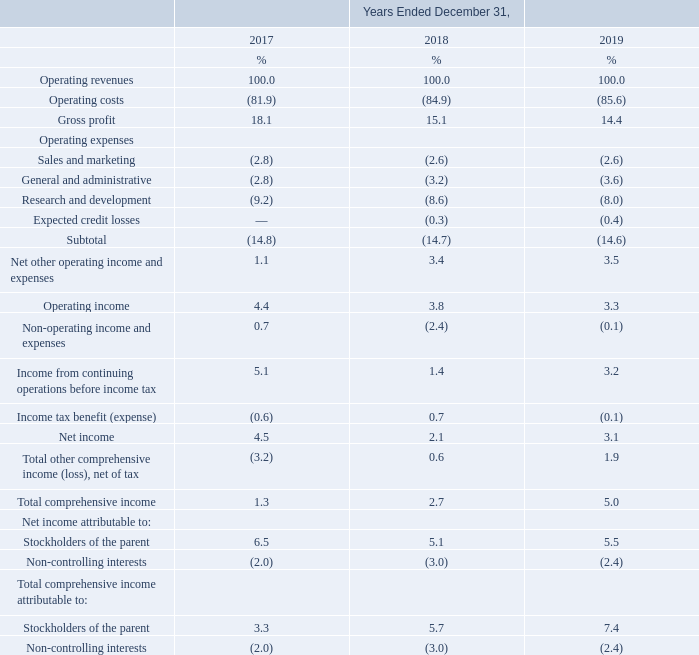Year Ended December 31, 2019 Compared to Year Ended December 31, 2018
Operating revenues. Operating revenues decreased by 2.0% from NT$151,253 million in 2018 to NT$148,202 million (US$4,955 million) in
2019, primarily due to decreased other operating revenues, decreased foundry wafer sale, and 2.5% depreciation of the NTD in 2019 from 2018. The decreased foundry wafer sale came from a decline of 2.9% in average selling price from 2018 to 2019, partially offset by a 1.1% increase in foundry wafer shipment from 7,108 thousand 8-inch equivalent wafers in 2018 to 7,189 thousand 8-inch equivalent wafers in 2019.
Operating costs. Operating costs decreased by 1.2% from NT$128,413 million in 2018 to NT$126,887 million (US$4,242 million) in 2019, primarily due to the decreased depreciation expense and other operating costs, which was partially offset by the increased direct material costs.
Gross profit and gross margin. Gross profit decreased from NT$22,840 million in 2018 to NT$21,315 million (US$713 million) in 2019. Our gross margin decreased from 15.1% in 2018 to 14.4% in 2019, primarily due to an annual decline of 2.9% in average selling price.
Why did the Operating revenues decreased from 2018 to 2019?  Primarily due to decreased other operating revenues, decreased foundry wafer sale, and 2.5% depreciation of the ntd in 2019 from 2018. Why did the Operating costs decreased from 2018 to 2019? Primarily due to the decreased depreciation expense and other operating costs, which was partially offset by the increased direct material costs. Why did the gross margin decreased from 2018 to 2019? Primarily due to an annual decline of 2.9% in average selling price. What is the average of Gross profit?
Answer scale should be: percent. (18.1+15.1+14.4) / 3
Answer: 15.87. What is the average Operating expenses?
Answer scale should be: percent. (14.8+14.7+14.6) / 3
Answer: 14.7. What is the average Operating income?
Answer scale should be: percent. (4.4+3.8+3.3) / 3
Answer: 3.83. 